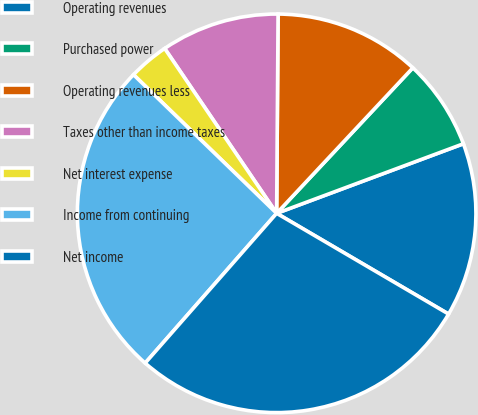<chart> <loc_0><loc_0><loc_500><loc_500><pie_chart><fcel>Operating revenues<fcel>Purchased power<fcel>Operating revenues less<fcel>Taxes other than income taxes<fcel>Net interest expense<fcel>Income from continuing<fcel>Net income<nl><fcel>14.11%<fcel>7.35%<fcel>11.86%<fcel>9.61%<fcel>3.26%<fcel>25.78%<fcel>28.03%<nl></chart> 